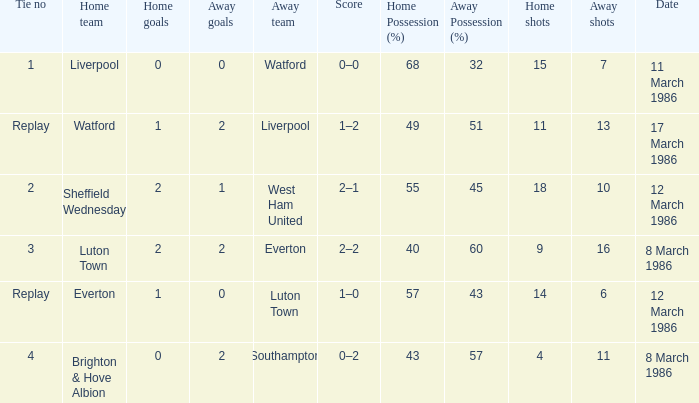What was the tie resulting from Sheffield Wednesday's game? 2.0. 